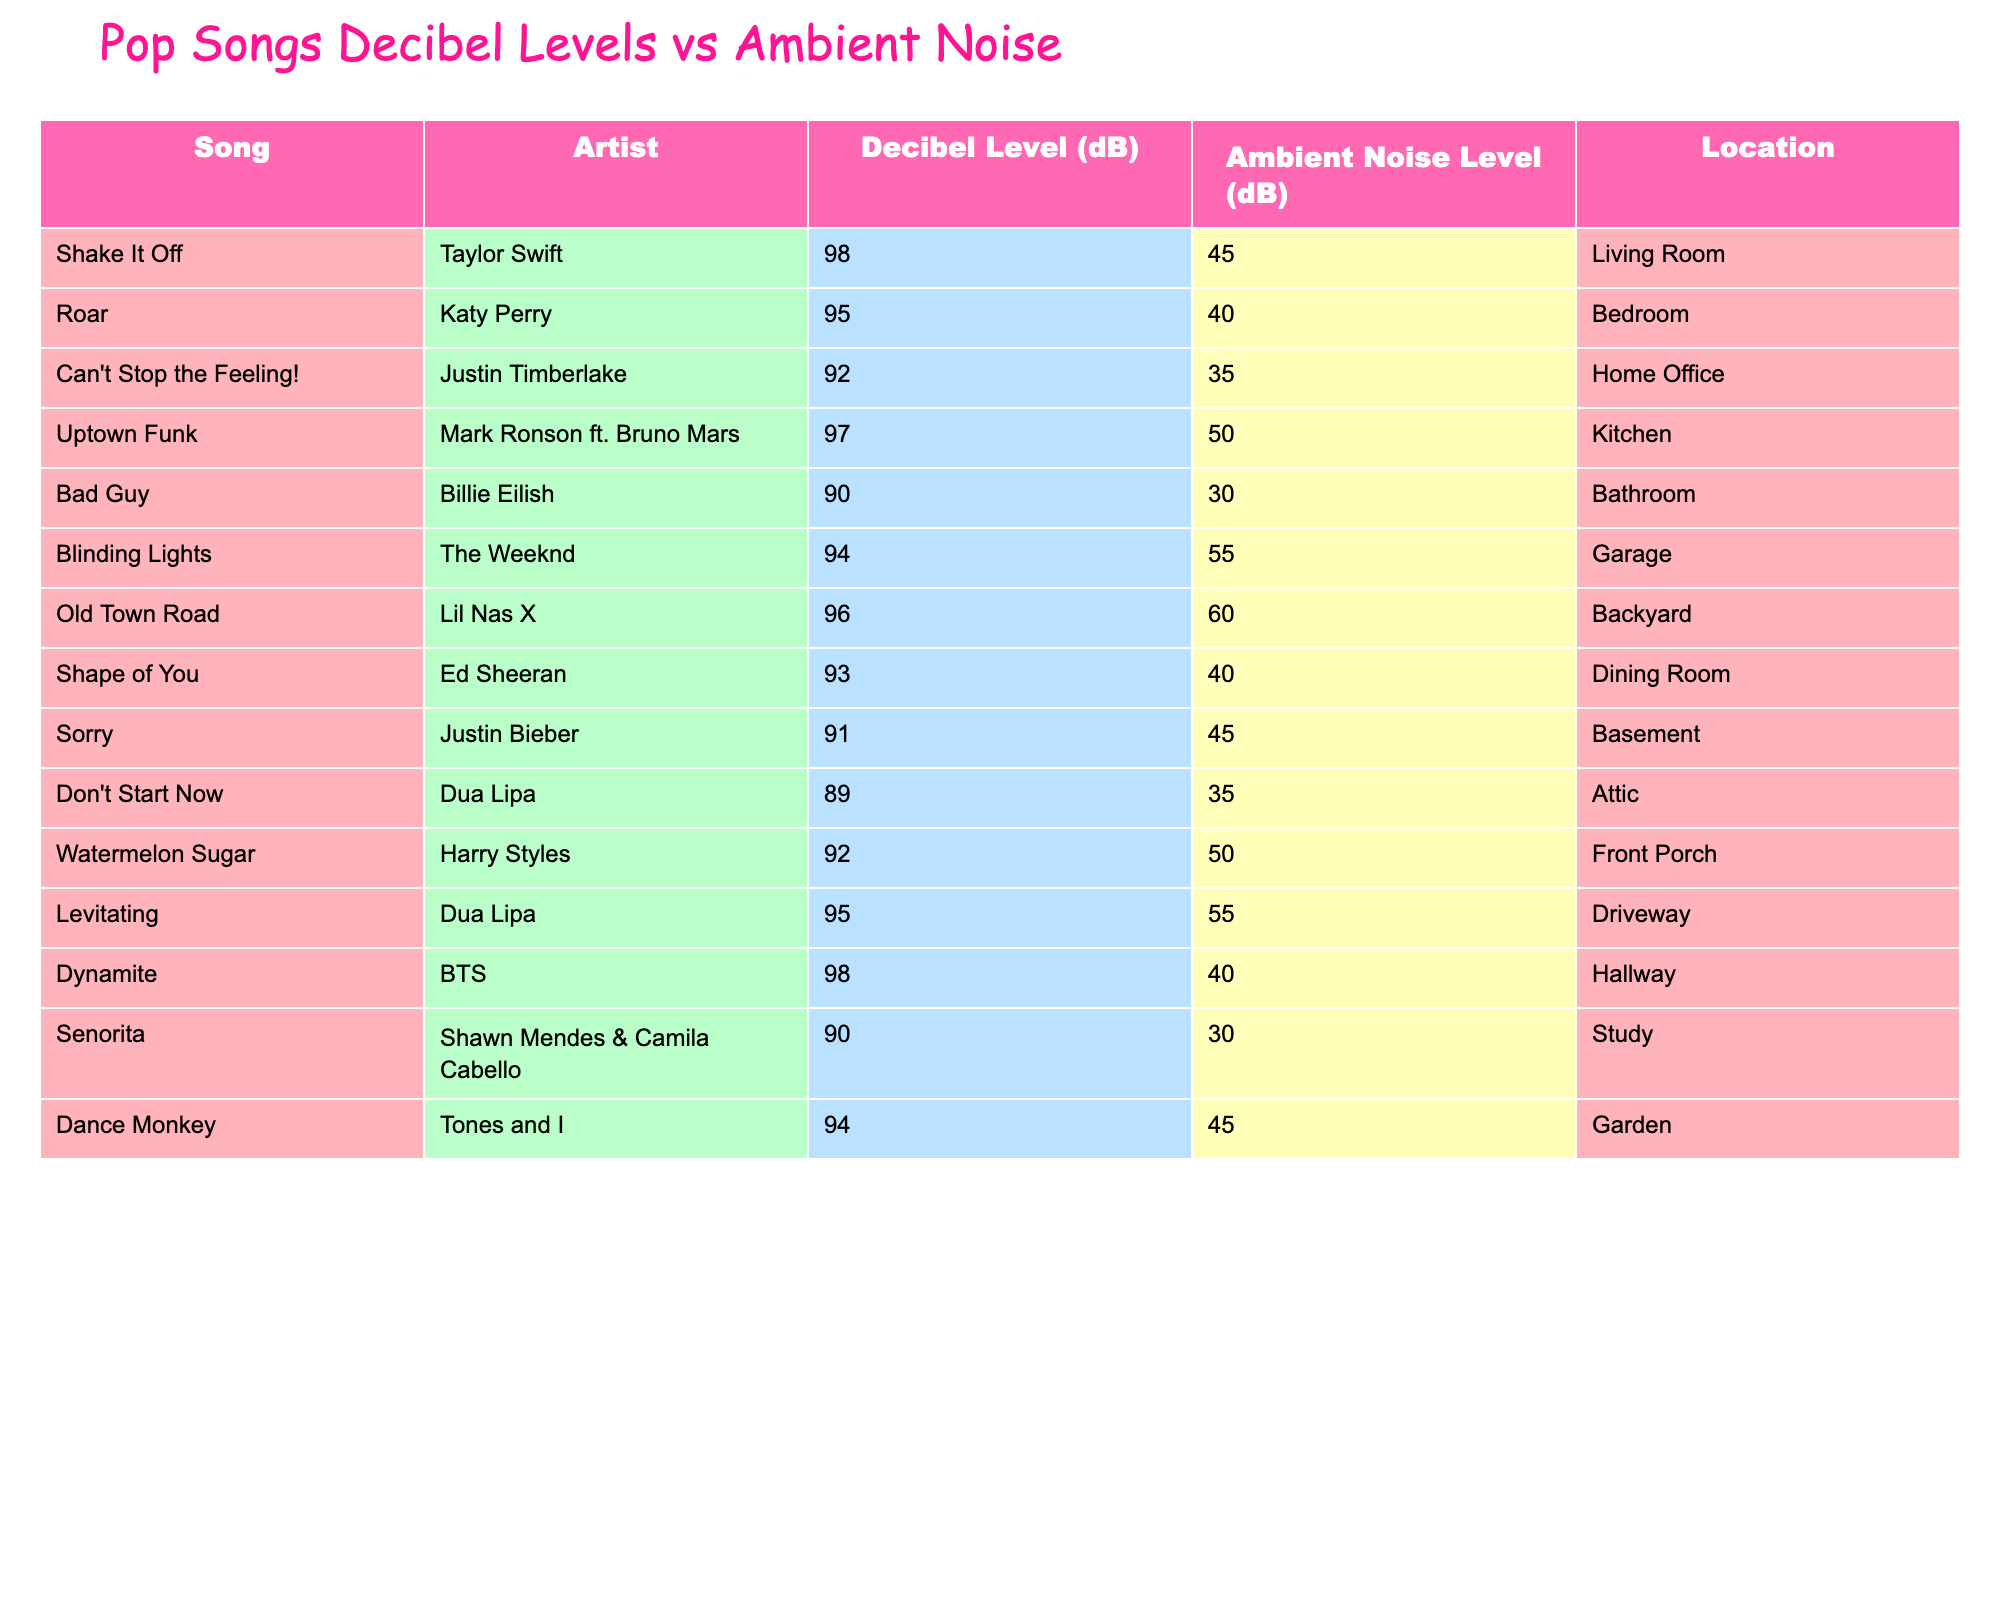What song has the highest decibel level? The table lists the decibel levels for each song, and "Shake It Off" and "Dynamite" both have the highest level at 98 dB.
Answer: Shake It Off and Dynamite Which song is the loudest in the bathroom? According to the table, "Bad Guy" is played at 90 dB, which is the only song listed for the bathroom.
Answer: Bad Guy What is the ambient noise level in the kitchen? The table shows that the ambient noise level in the kitchen is 50 dB.
Answer: 50 dB What is the average decibel level for all songs? To find the average, add all the decibel levels: (98 + 95 + 92 + 97 + 90 + 94 + 96 + 93 + 91 + 89 + 92 + 95 + 98 + 90 + 94) = 1390. There are 15 songs, so the average is 1390/15 = 92.67 dB.
Answer: 92.67 dB Which song has a decibel level that is more than 10 dB louder than its ambient noise level? To determine this, subtract the ambient noise level from the decibel level for each song. "Shake It Off" (98-45), "Uptown Funk" (97-50), "Dynamite" (98-40), and "Old Town Road" (96-60) all have more than 10 dB difference.
Answer: Shake It Off, Uptown Funk, Dynamite, Old Town Road Is the ambient noise level in the garage higher than in the living room? The ambient noise level in the garage is 55 dB, while in the living room it is 45 dB. Since 55 dB is greater than 45 dB, the statement is true.
Answer: Yes What is the difference in decibel levels between "Can't Stop the Feeling!" and "Shape of You"? The decibel level for "Can't Stop the Feeling!" is 92 dB and for "Shape of You" it is 93 dB. The difference is 93 - 92 = 1 dB.
Answer: 1 dB Are there more songs with decibel levels above 90 dB or below 90 dB? Counting each category: There are 8 songs with decibel levels above 90 dB (Shake It Off, Roar, Uptown Funk, Blinding Lights, Old Town Road, Shape of You, Levitating, Dynamite) and 7 songs below 90 dB (Bad Guy, Sorry, Don't Start Now, Senorita). So there are more songs above 90 dB.
Answer: Above 90 dB Which song has the lowest ambient noise level and where is it located? The lowest ambient noise level is 30 dB, which is for both "Bad Guy" and "Senorita," located in the bathroom and study, respectively.
Answer: Bad Guy and Senorita in bathroom and study What is the sum of the ambient noise levels for all songs? Adding the ambient noise levels: (45 + 40 + 35 + 50 + 30 + 55 + 60 + 40 + 45 + 35 + 50 + 55 + 40 + 30 + 45) = 605 dB.
Answer: 605 dB 